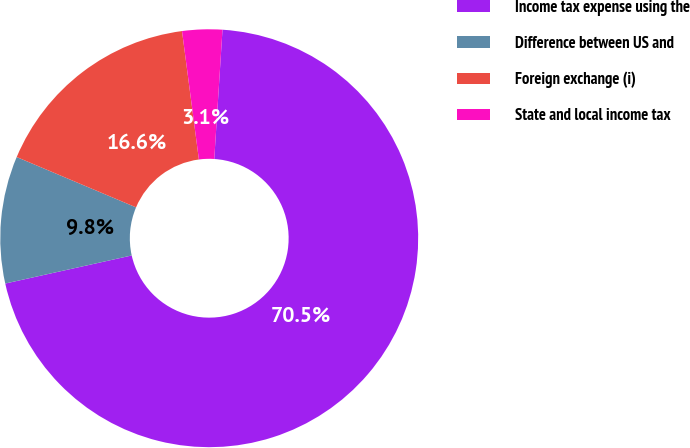Convert chart. <chart><loc_0><loc_0><loc_500><loc_500><pie_chart><fcel>Income tax expense using the<fcel>Difference between US and<fcel>Foreign exchange (i)<fcel>State and local income tax<nl><fcel>70.51%<fcel>9.83%<fcel>16.57%<fcel>3.09%<nl></chart> 